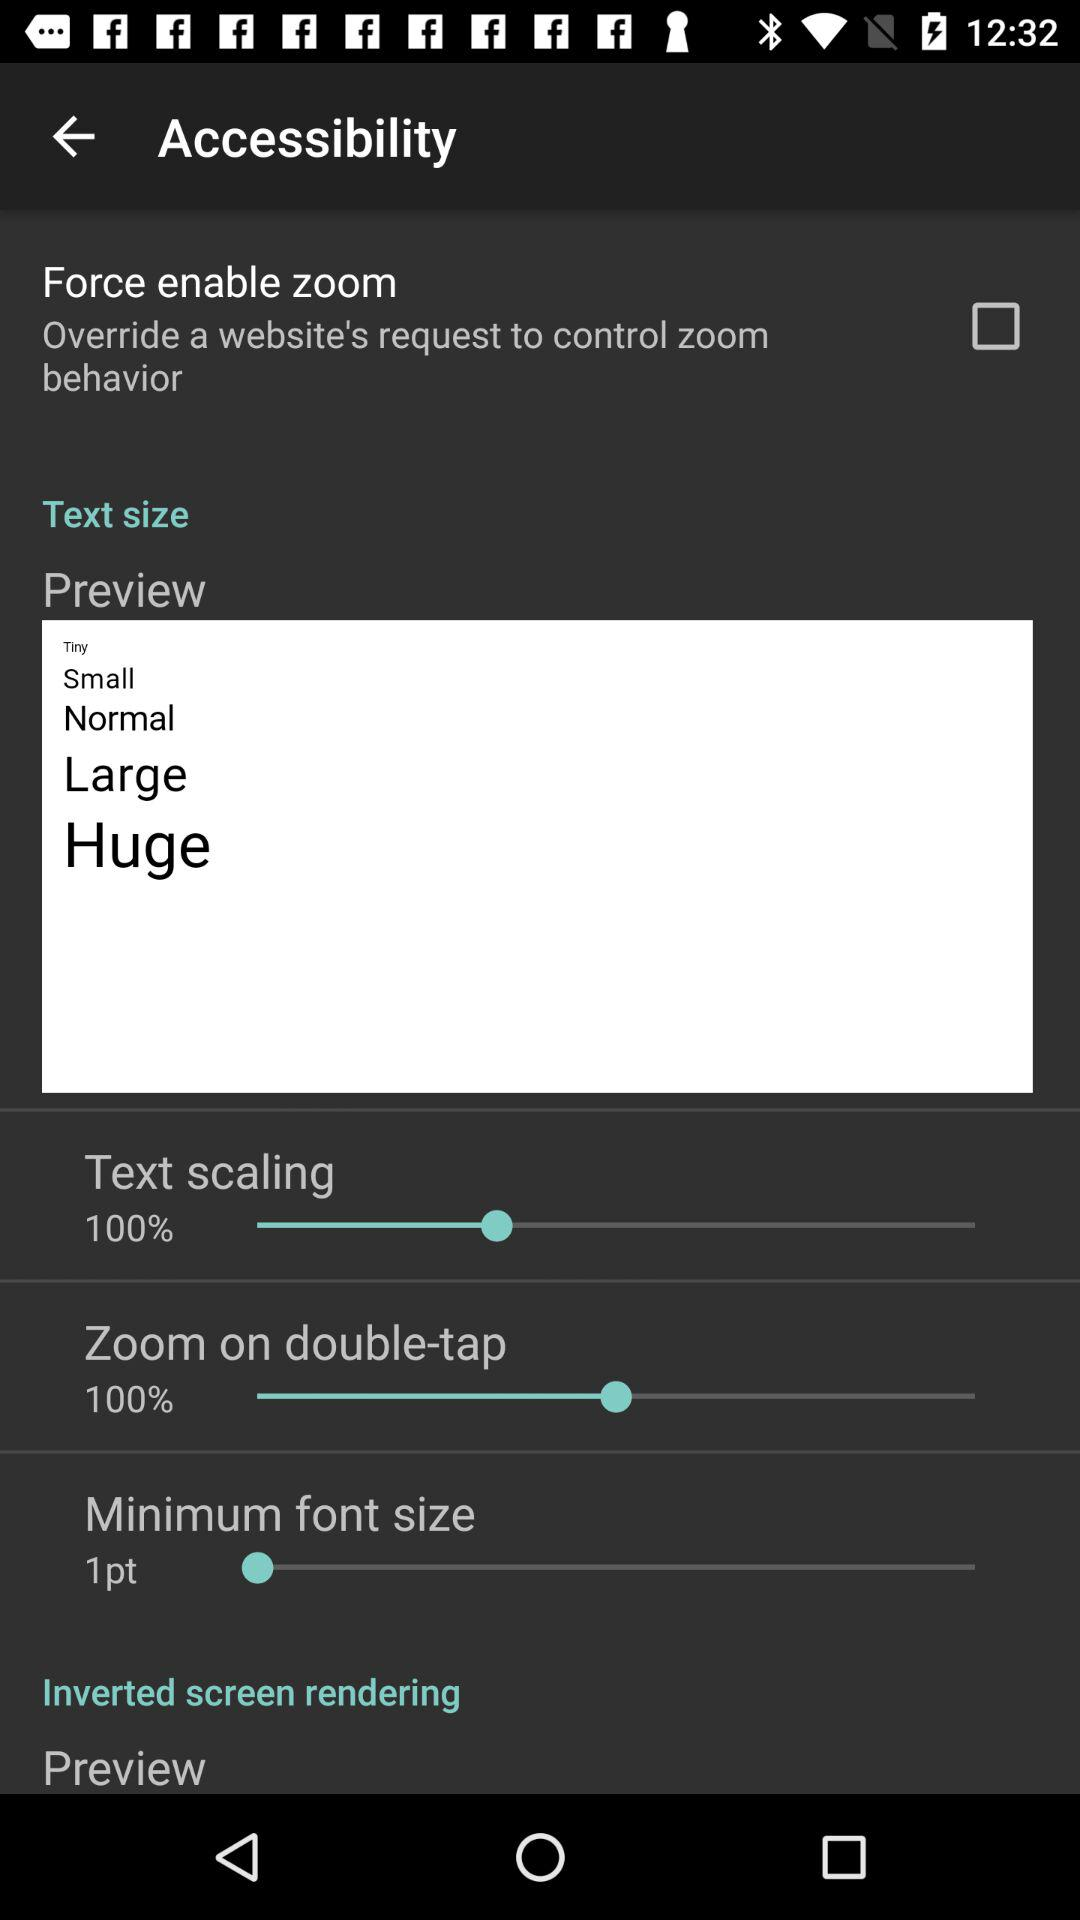How many options are there for text size?
Answer the question using a single word or phrase. 4 